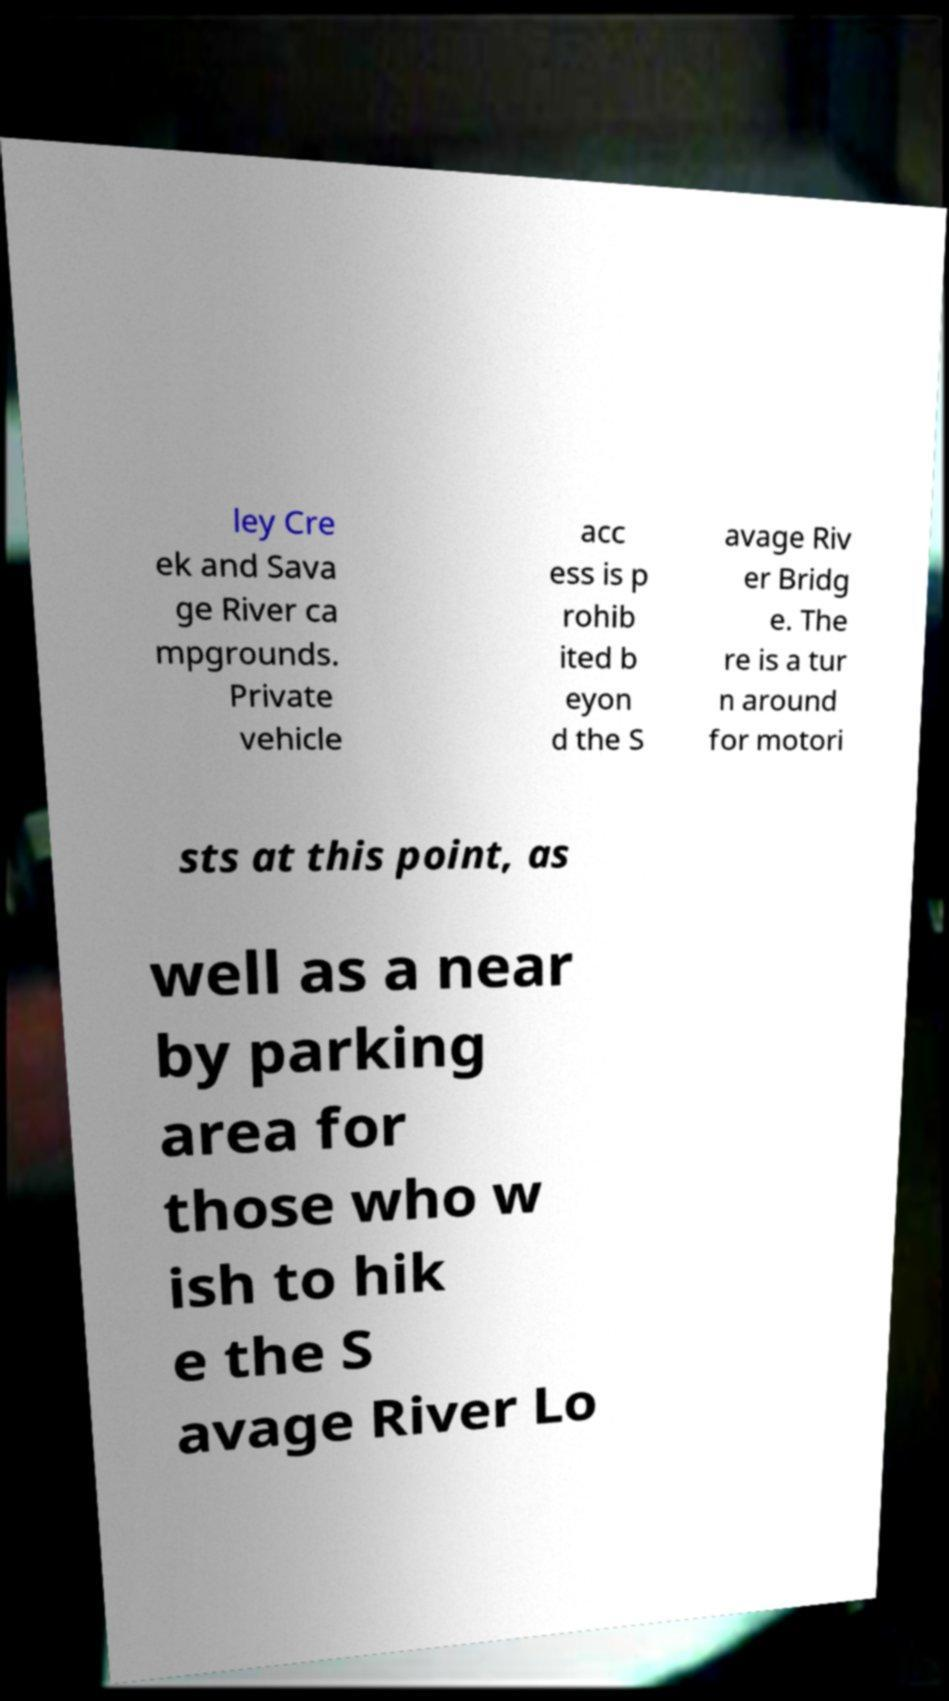Please read and relay the text visible in this image. What does it say? ley Cre ek and Sava ge River ca mpgrounds. Private vehicle acc ess is p rohib ited b eyon d the S avage Riv er Bridg e. The re is a tur n around for motori sts at this point, as well as a near by parking area for those who w ish to hik e the S avage River Lo 